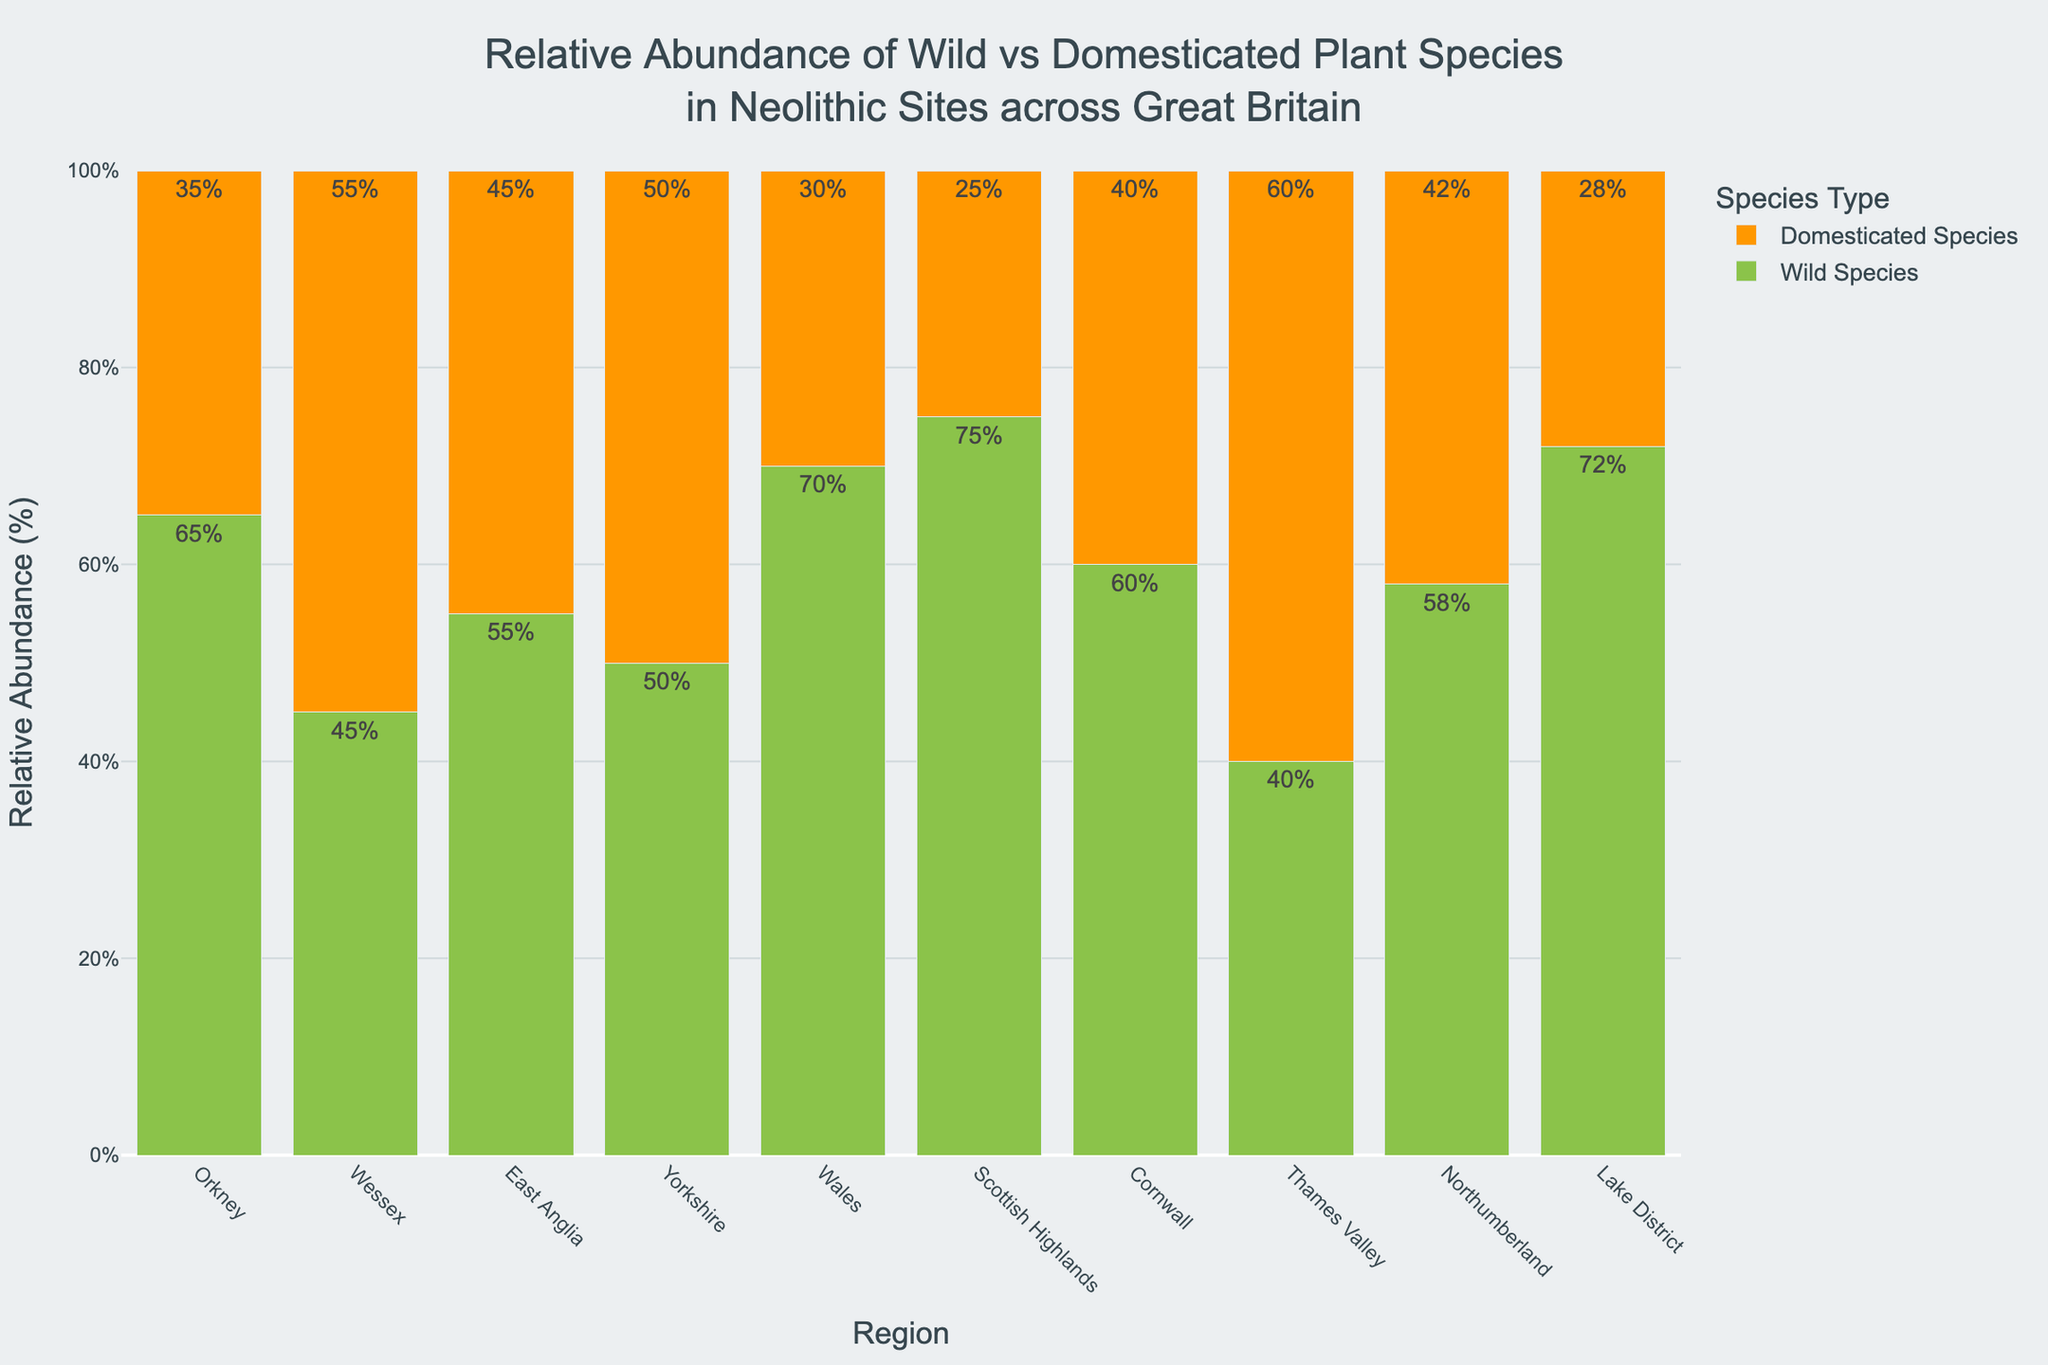Which region has the highest percentage of wild plant species? Look at the bar heights for wild species; the tallest bar indicates the highest percentage of wild plant species. The Scottish Highlands have the highest bar at 75%.
Answer: Scottish Highlands What's the average percentage of domesticated species in the Lake District and Orkney together? Add the domesticated percentages for Lake District (28%) and Orkney (35%), then divide by 2. (28 + 35) / 2 = 63 / 2 = 31.5%
Answer: 31.5% Which region shows an equal percentage of wild and domesticated plant species? Identify the region where both bars representing wild and domesticated species have the same height. Yorkshire has both bars at 50%.
Answer: Yorkshire What is the total percentage of wild species in the Orkney and Wessex regions combined? Add the percentages of wild species for Orkney (65%) and Wessex (45%). 65 + 45 = 110%
Answer: 110% Which region has the greatest difference between the percentages of wild and domesticated plant species? Calculate the difference for each region and compare them. The Scottish Highlands have a difference of 75% - 25% = 50%, which is the highest.
Answer: Scottish Highlands In which regions is the percentage of domesticated species higher than wild species? Identify regions where the bar for domesticated species is taller than the bar for wild species. This happens in Wessex (55% vs. 45%) and Thames Valley (60% vs. 40%).
Answer: Wessex, Thames Valley What is the percentage range of domesticated species across all regions? Identify the minimum and maximum percentages for domesticated species: The highest is 60% in Thames Valley, and the lowest is 25% in Scottish Highlands. The range is 60% - 25% = 35%.
Answer: 35% Compare the total percentages of wild species between Wales and Northumberland. Which is greater? Calculate the total percentages for wild species in both regions: Wales has 70%, and Northumberland has 58%. 70% is greater than 58%.
Answer: Wales How much more abundant are wild species compared to domesticated species in Cornwall? Subtract the percentage of domesticated species from wild species: 60% - 40% = 20%. Wild species are 20% more abundant in Cornwall.
Answer: 20% 